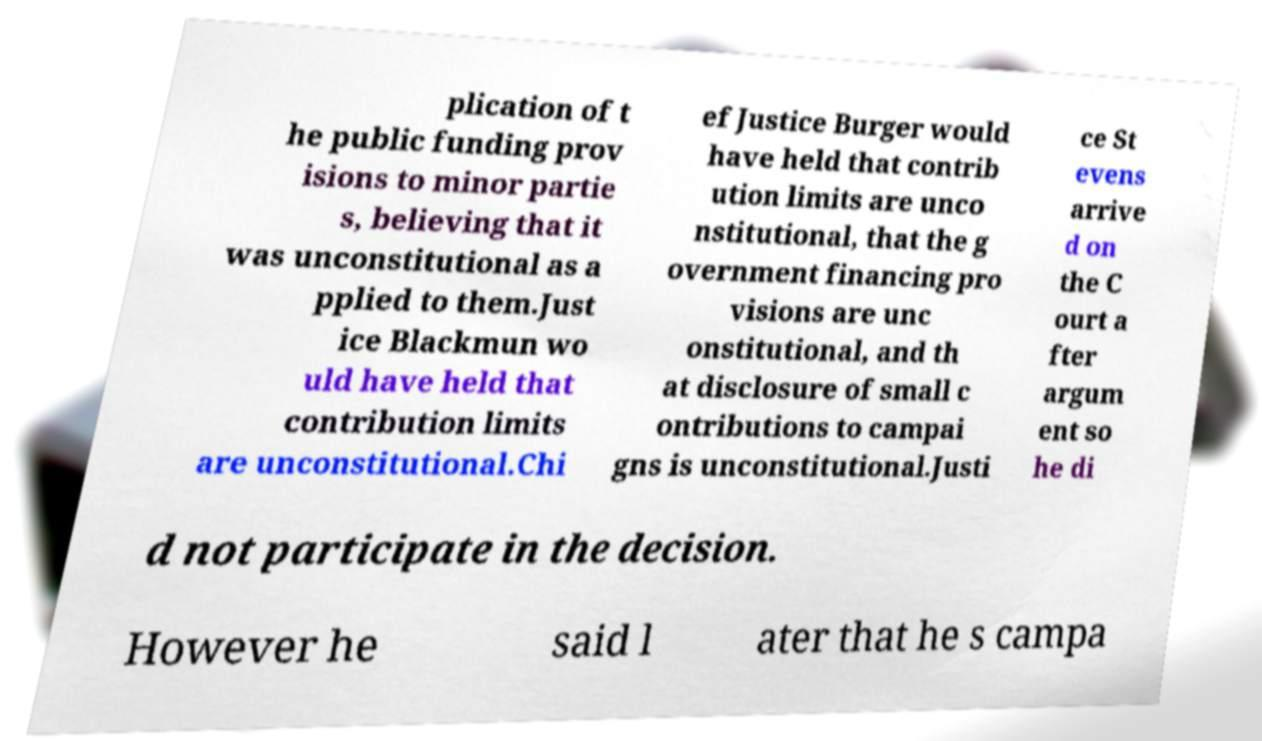Could you assist in decoding the text presented in this image and type it out clearly? plication of t he public funding prov isions to minor partie s, believing that it was unconstitutional as a pplied to them.Just ice Blackmun wo uld have held that contribution limits are unconstitutional.Chi ef Justice Burger would have held that contrib ution limits are unco nstitutional, that the g overnment financing pro visions are unc onstitutional, and th at disclosure of small c ontributions to campai gns is unconstitutional.Justi ce St evens arrive d on the C ourt a fter argum ent so he di d not participate in the decision. However he said l ater that he s campa 